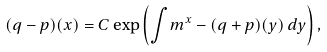<formula> <loc_0><loc_0><loc_500><loc_500>( q - p ) ( x ) = C \exp \left ( \int _ { \ } m ^ { x } - ( q + p ) ( y ) \, d y \right ) ,</formula> 